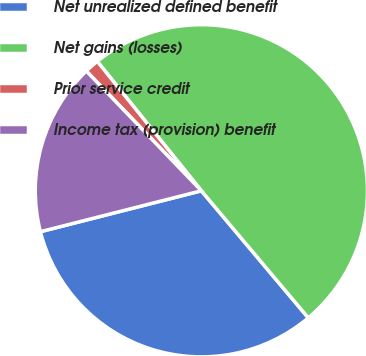Convert chart. <chart><loc_0><loc_0><loc_500><loc_500><pie_chart><fcel>Net unrealized defined benefit<fcel>Net gains (losses)<fcel>Prior service credit<fcel>Income tax (provision) benefit<nl><fcel>32.17%<fcel>49.65%<fcel>1.4%<fcel>16.78%<nl></chart> 